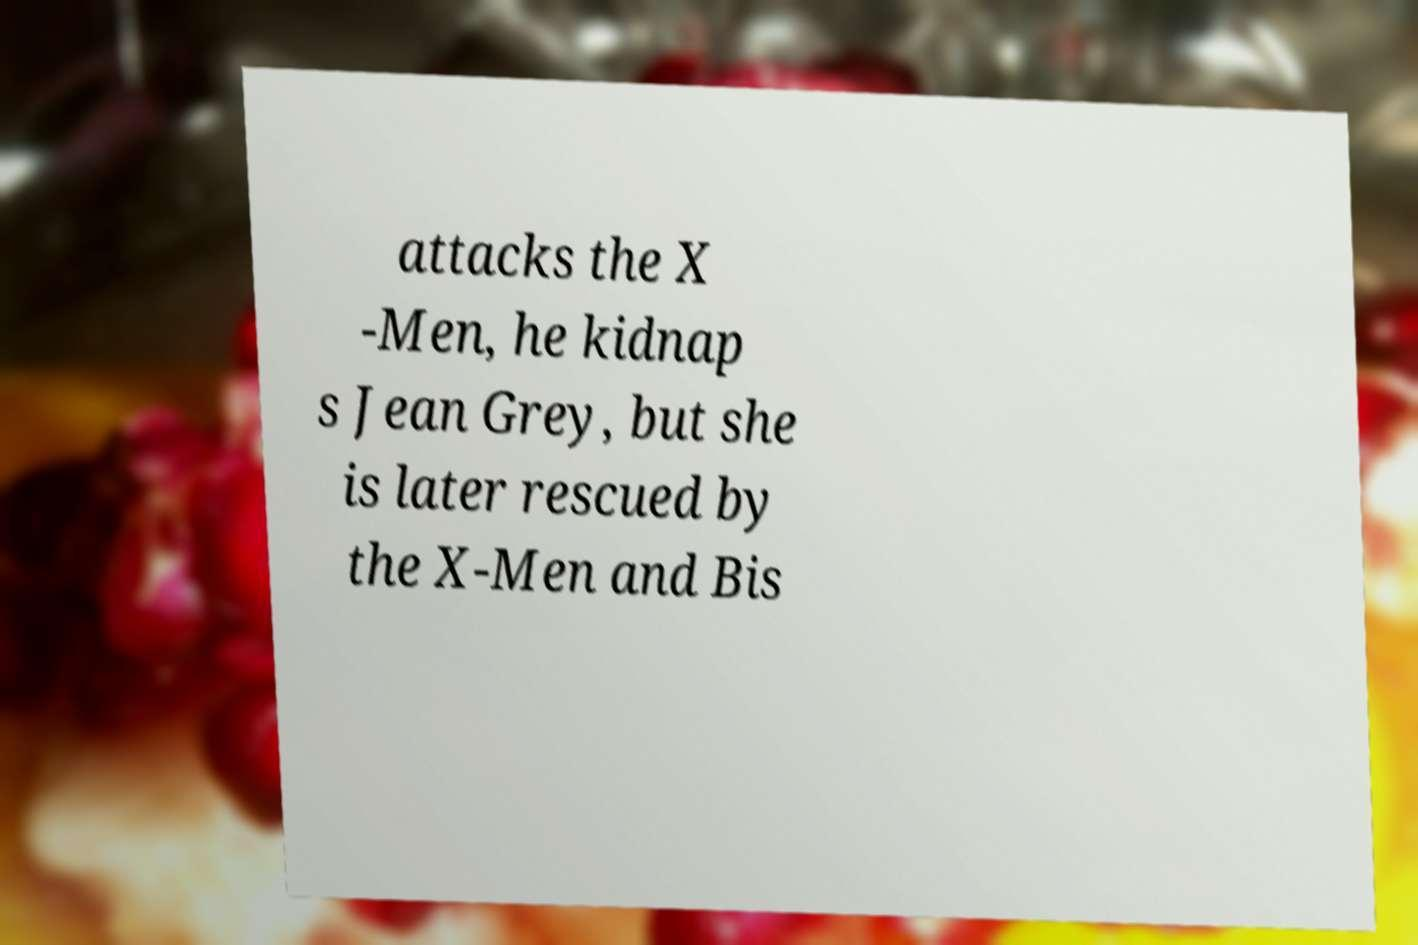Please read and relay the text visible in this image. What does it say? attacks the X -Men, he kidnap s Jean Grey, but she is later rescued by the X-Men and Bis 